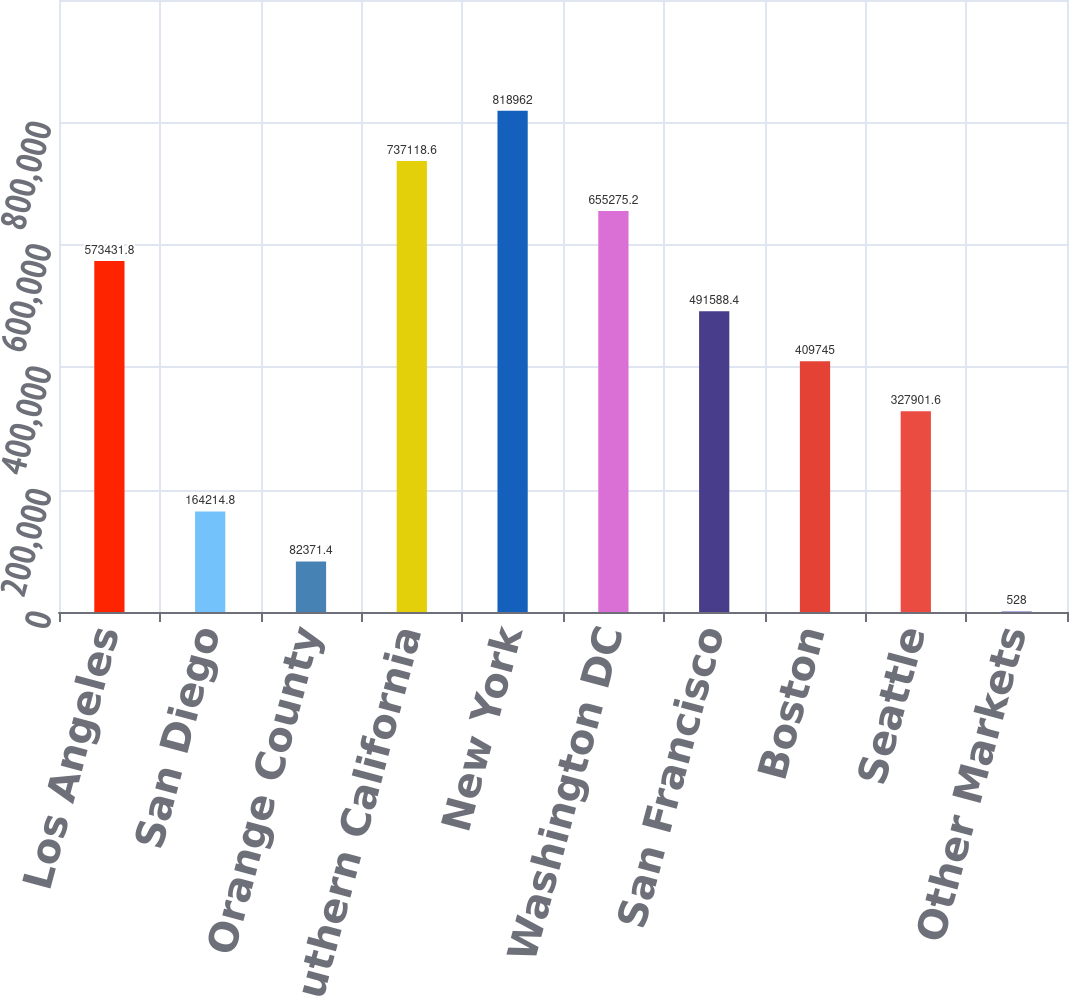Convert chart. <chart><loc_0><loc_0><loc_500><loc_500><bar_chart><fcel>Los Angeles<fcel>San Diego<fcel>Orange County<fcel>Subtotal - Southern California<fcel>New York<fcel>Washington DC<fcel>San Francisco<fcel>Boston<fcel>Seattle<fcel>Other Markets<nl><fcel>573432<fcel>164215<fcel>82371.4<fcel>737119<fcel>818962<fcel>655275<fcel>491588<fcel>409745<fcel>327902<fcel>528<nl></chart> 